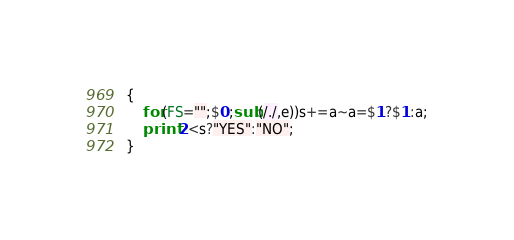<code> <loc_0><loc_0><loc_500><loc_500><_Awk_>{
    for(FS="";$0;sub(/./,e))s+=a~a=$1?$1:a;
    print 2<s?"YES":"NO";
}</code> 